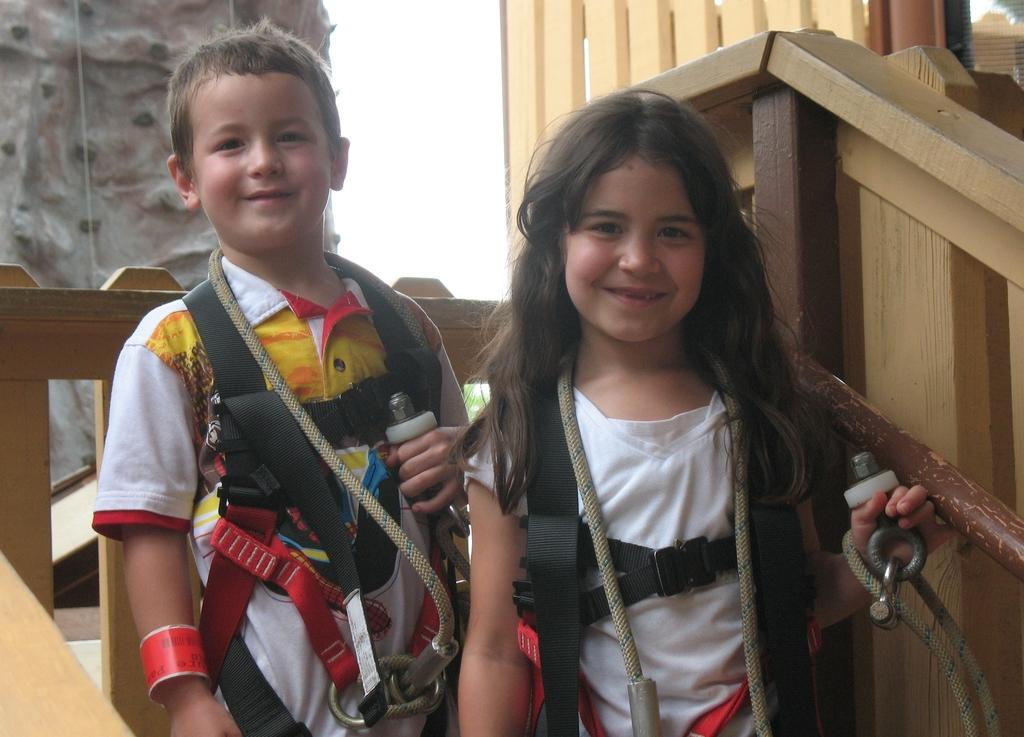Who is present in the image? There is a boy and a girl in the image. What are the expressions on their faces? Both the boy and girl are smiling. What are they wearing that is related to climbing or outdoor activities? They are wearing ropes and carabiners. What can be seen in the background of the image? There is a wooden fence in the background of the image. What type of ray is visible in the image? There is no ray present in the image. What is the girl holding in the basket in the image? There is no basket or any items related to a basket in the image. 